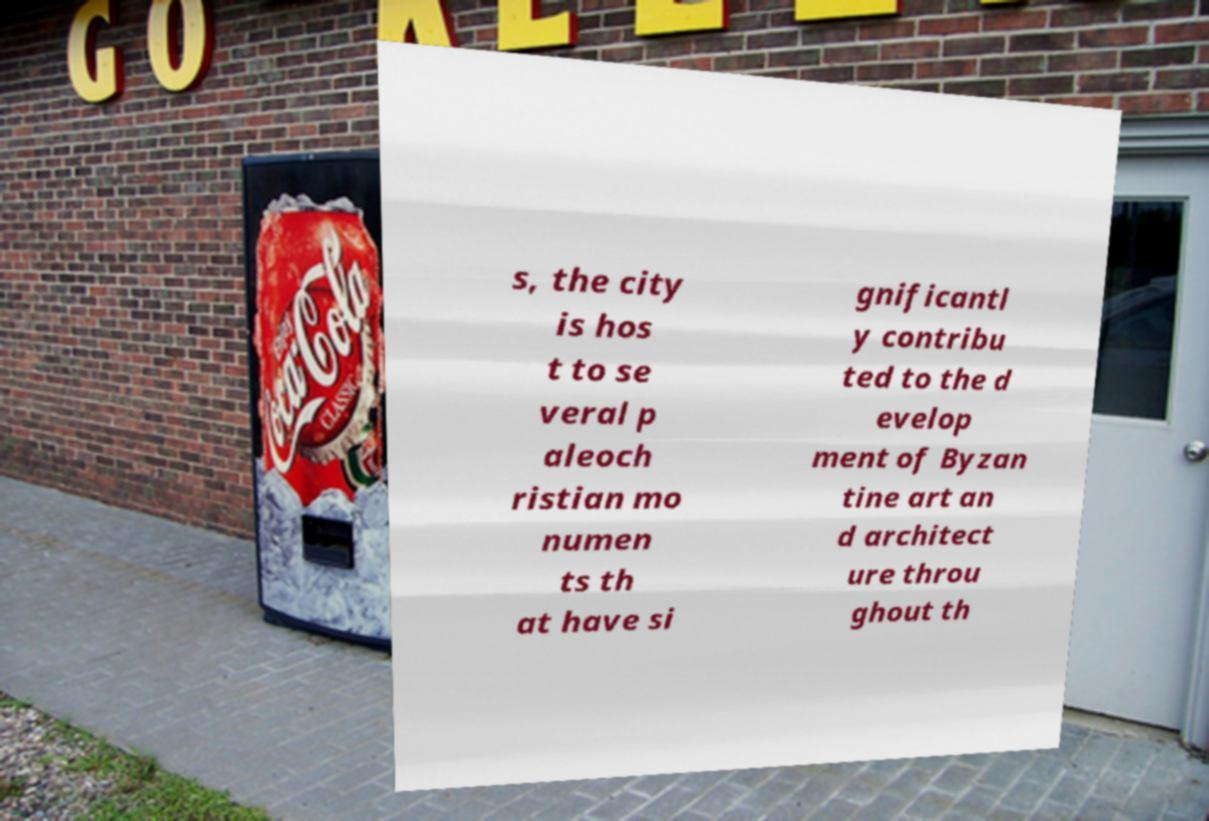I need the written content from this picture converted into text. Can you do that? s, the city is hos t to se veral p aleoch ristian mo numen ts th at have si gnificantl y contribu ted to the d evelop ment of Byzan tine art an d architect ure throu ghout th 